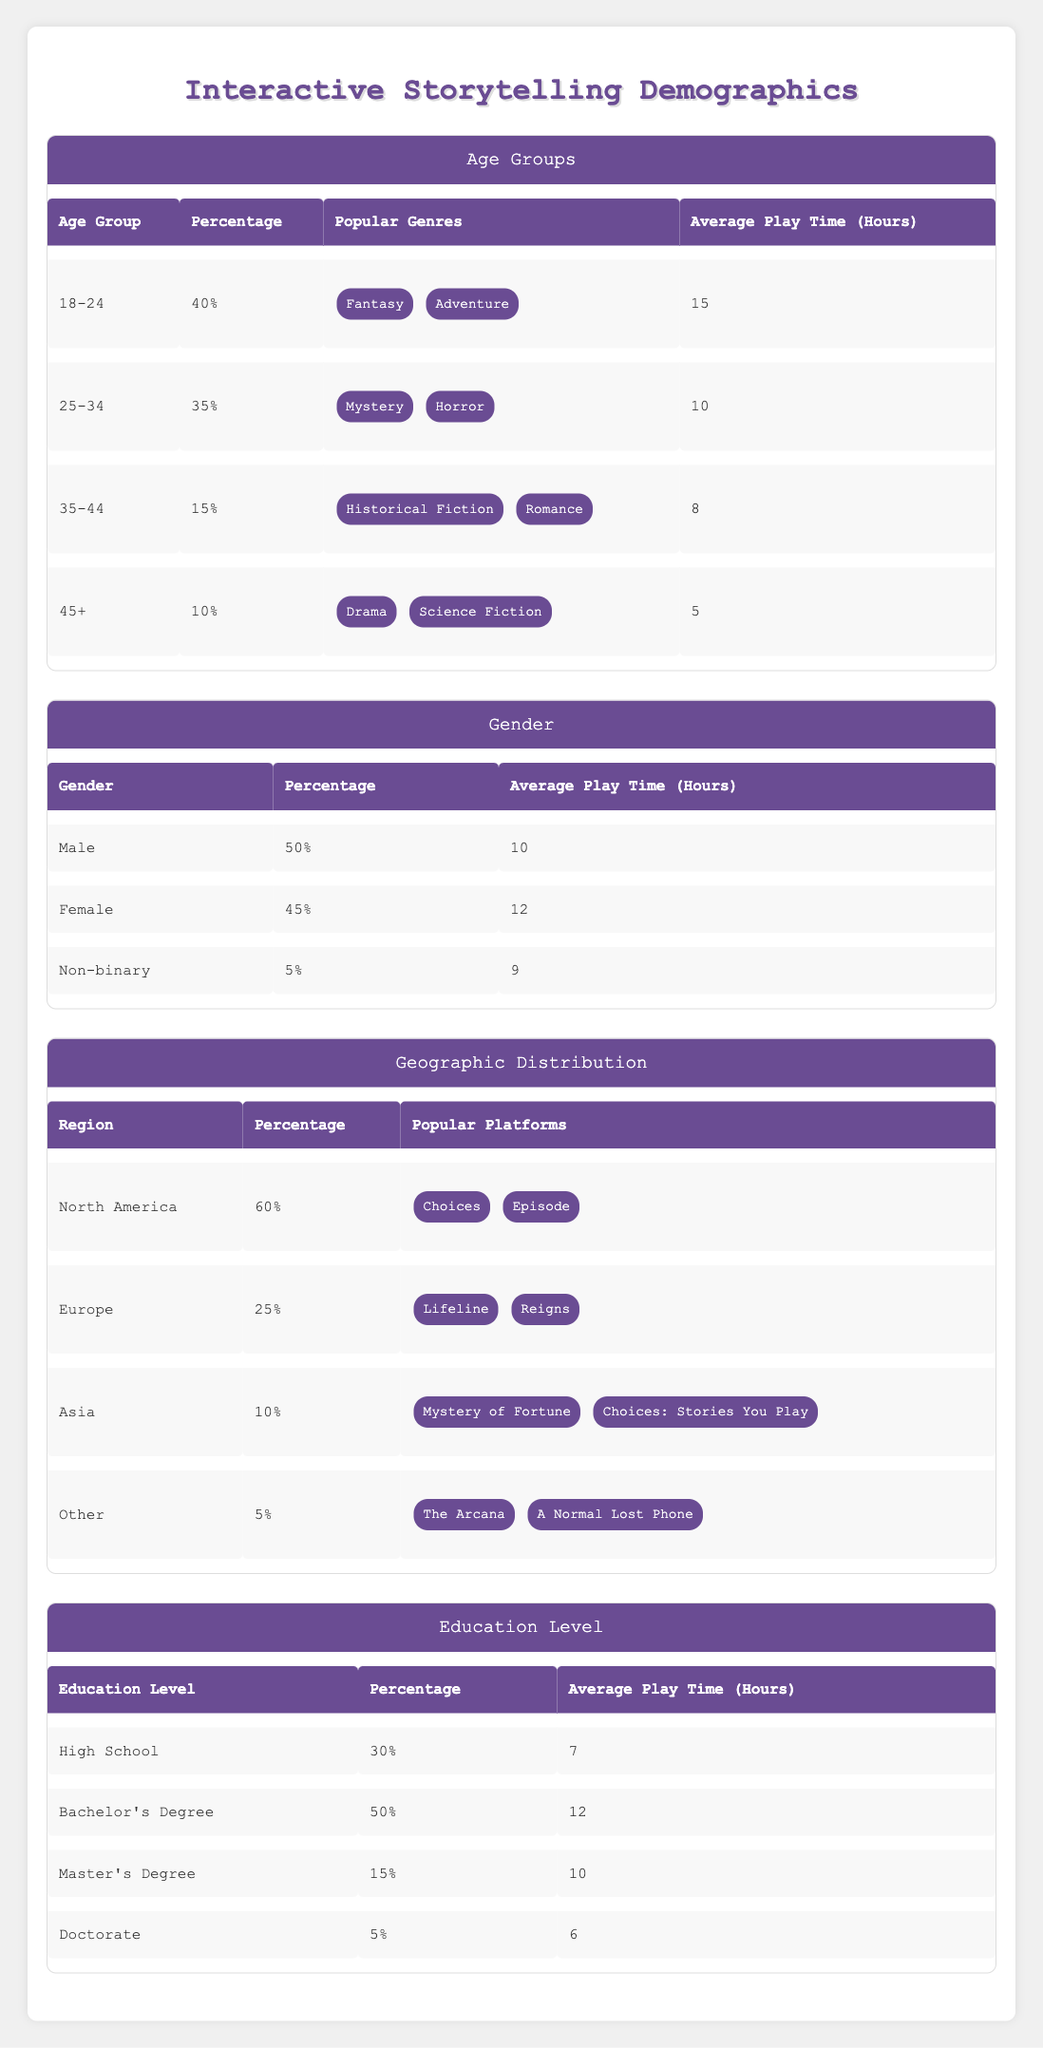What percentage of players are aged 18-24? The table shows that the age group 18-24 has a percentage value listed under the Age Groups section. Specifically, it is 40%.
Answer: 40% Which age group has the highest average play time? By comparing the average play times across all age groups in the Age Groups section, we find that 18-24 has 15 hours, which is higher than the others: 25-34 has 10 hours, 35-44 has 8 hours, and 45+ has 5 hours.
Answer: 18-24 What is the average play time for females? The table specifies that females have an average play time of 12 hours under the Gender section.
Answer: 12 Are males the largest gender demographic among players? The table indicates that males make up 50% of the players, which is higher than females at 45% and non-binary at 5%. Therefore, the statement is true.
Answer: Yes What is the total percentage of players from North America and Europe combined? To find the total percentage from North America (60%) and Europe (25%), we sum these values: 60 + 25 = 85%.
Answer: 85% What is the least common education level among players, and what is its average play time? In the Education Level section, the least common education level is Doctorate at 5%, with an average play time of 6 hours.
Answer: Doctorate, 6 Does the demographic data indicate that players who have a bachelor's degree play more hours on average than those with a master's degree? Comparing average play times, bachelor's degree holders play 12 hours on average while master's degree holders play 10 hours on average, confirming that bachelor's degree holders play more.
Answer: Yes What percentage of players aged 35-44 prefer Historical Fiction? The table does not provide a direct percentage of preference for Historical Fiction; it only states that this genre is popular among the 35-44 age group, which comprises 15% of the player base. However, it does not specify how many of these players prefer Historical Fiction specifically.
Answer: Not available What is the average play time among non-binary players compared to high school graduates? Non-binary players average 9 hours as indicated in the Gender section, whereas high school graduates average 7 hours as noted in the Education Level section. Thus, non-binary players have a higher average play time.
Answer: Non-binary players average more 